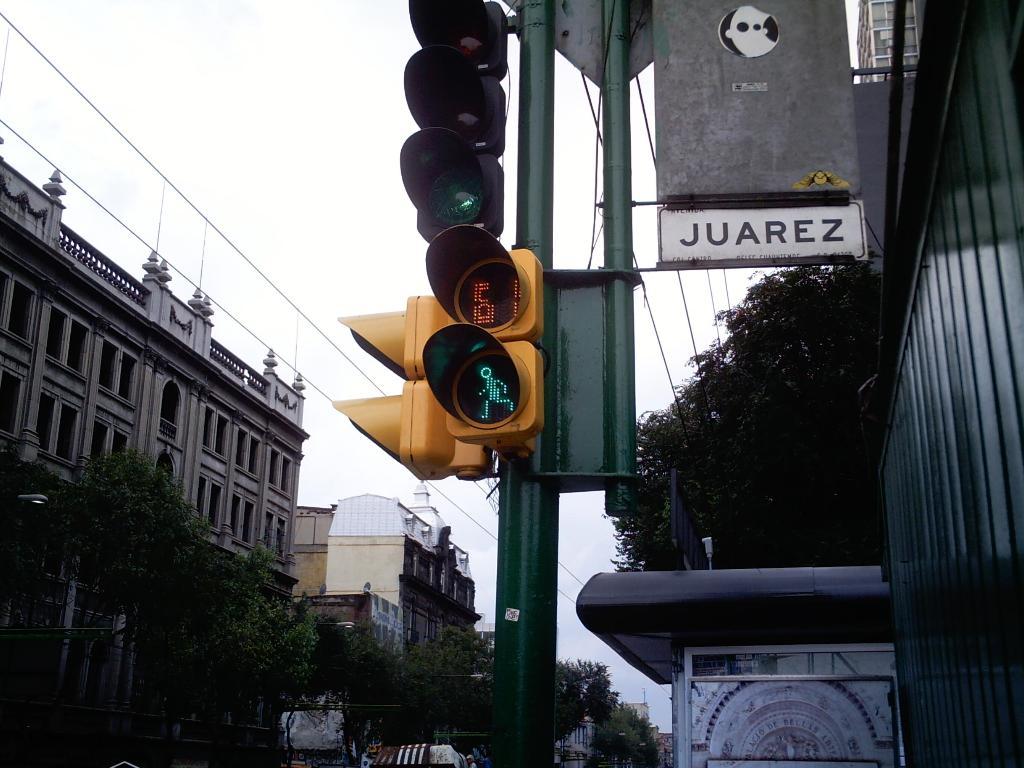Where is this?
Your answer should be very brief. Juarez. How much time is left for pedestrians to walk on the crosswalk?
Offer a terse response. 6. 